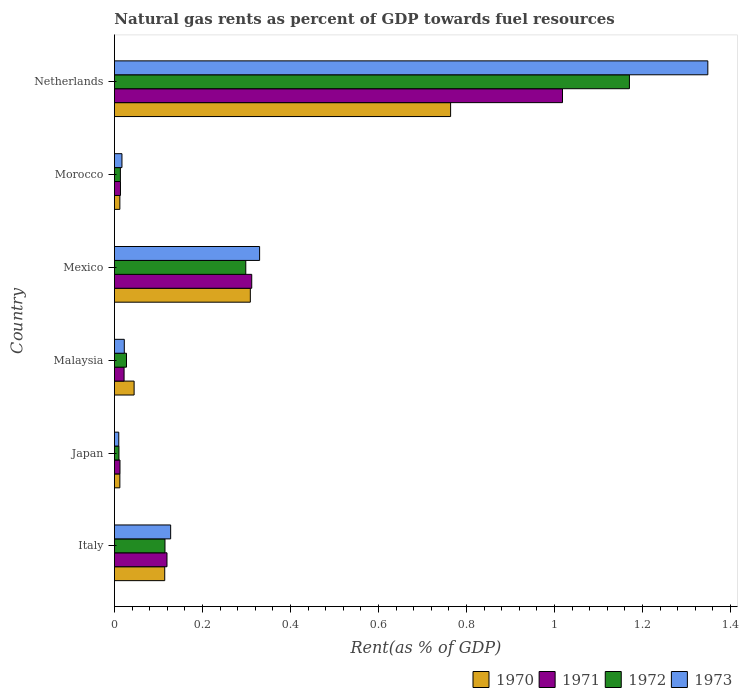How many different coloured bars are there?
Your response must be concise. 4. Are the number of bars per tick equal to the number of legend labels?
Your answer should be very brief. Yes. What is the label of the 2nd group of bars from the top?
Ensure brevity in your answer.  Morocco. What is the matural gas rent in 1973 in Netherlands?
Make the answer very short. 1.35. Across all countries, what is the maximum matural gas rent in 1971?
Provide a succinct answer. 1.02. Across all countries, what is the minimum matural gas rent in 1970?
Ensure brevity in your answer.  0.01. In which country was the matural gas rent in 1970 minimum?
Offer a terse response. Japan. What is the total matural gas rent in 1970 in the graph?
Provide a succinct answer. 1.26. What is the difference between the matural gas rent in 1973 in Japan and that in Mexico?
Ensure brevity in your answer.  -0.32. What is the difference between the matural gas rent in 1971 in Morocco and the matural gas rent in 1973 in Mexico?
Ensure brevity in your answer.  -0.32. What is the average matural gas rent in 1972 per country?
Ensure brevity in your answer.  0.27. What is the difference between the matural gas rent in 1970 and matural gas rent in 1973 in Netherlands?
Provide a succinct answer. -0.58. In how many countries, is the matural gas rent in 1971 greater than 0.28 %?
Provide a short and direct response. 2. What is the ratio of the matural gas rent in 1970 in Japan to that in Morocco?
Provide a succinct answer. 1. Is the difference between the matural gas rent in 1970 in Morocco and Netherlands greater than the difference between the matural gas rent in 1973 in Morocco and Netherlands?
Ensure brevity in your answer.  Yes. What is the difference between the highest and the second highest matural gas rent in 1973?
Keep it short and to the point. 1.02. What is the difference between the highest and the lowest matural gas rent in 1971?
Give a very brief answer. 1.01. Is the sum of the matural gas rent in 1971 in Malaysia and Morocco greater than the maximum matural gas rent in 1972 across all countries?
Offer a terse response. No. Is it the case that in every country, the sum of the matural gas rent in 1971 and matural gas rent in 1970 is greater than the sum of matural gas rent in 1972 and matural gas rent in 1973?
Your answer should be very brief. No. What does the 2nd bar from the top in Netherlands represents?
Provide a succinct answer. 1972. What does the 1st bar from the bottom in Japan represents?
Your answer should be very brief. 1970. Are all the bars in the graph horizontal?
Offer a very short reply. Yes. How are the legend labels stacked?
Offer a very short reply. Horizontal. What is the title of the graph?
Give a very brief answer. Natural gas rents as percent of GDP towards fuel resources. What is the label or title of the X-axis?
Offer a terse response. Rent(as % of GDP). What is the Rent(as % of GDP) of 1970 in Italy?
Provide a short and direct response. 0.11. What is the Rent(as % of GDP) in 1971 in Italy?
Provide a succinct answer. 0.12. What is the Rent(as % of GDP) in 1972 in Italy?
Make the answer very short. 0.11. What is the Rent(as % of GDP) in 1973 in Italy?
Your response must be concise. 0.13. What is the Rent(as % of GDP) in 1970 in Japan?
Ensure brevity in your answer.  0.01. What is the Rent(as % of GDP) in 1971 in Japan?
Provide a succinct answer. 0.01. What is the Rent(as % of GDP) in 1972 in Japan?
Your answer should be compact. 0.01. What is the Rent(as % of GDP) of 1973 in Japan?
Keep it short and to the point. 0.01. What is the Rent(as % of GDP) of 1970 in Malaysia?
Provide a succinct answer. 0.04. What is the Rent(as % of GDP) of 1971 in Malaysia?
Your answer should be very brief. 0.02. What is the Rent(as % of GDP) of 1972 in Malaysia?
Your response must be concise. 0.03. What is the Rent(as % of GDP) in 1973 in Malaysia?
Give a very brief answer. 0.02. What is the Rent(as % of GDP) of 1970 in Mexico?
Give a very brief answer. 0.31. What is the Rent(as % of GDP) in 1971 in Mexico?
Make the answer very short. 0.31. What is the Rent(as % of GDP) of 1972 in Mexico?
Your answer should be compact. 0.3. What is the Rent(as % of GDP) of 1973 in Mexico?
Provide a succinct answer. 0.33. What is the Rent(as % of GDP) in 1970 in Morocco?
Offer a terse response. 0.01. What is the Rent(as % of GDP) in 1971 in Morocco?
Your answer should be compact. 0.01. What is the Rent(as % of GDP) of 1972 in Morocco?
Provide a succinct answer. 0.01. What is the Rent(as % of GDP) of 1973 in Morocco?
Keep it short and to the point. 0.02. What is the Rent(as % of GDP) in 1970 in Netherlands?
Your answer should be compact. 0.76. What is the Rent(as % of GDP) in 1971 in Netherlands?
Give a very brief answer. 1.02. What is the Rent(as % of GDP) in 1972 in Netherlands?
Offer a terse response. 1.17. What is the Rent(as % of GDP) of 1973 in Netherlands?
Your answer should be compact. 1.35. Across all countries, what is the maximum Rent(as % of GDP) in 1970?
Make the answer very short. 0.76. Across all countries, what is the maximum Rent(as % of GDP) of 1971?
Provide a succinct answer. 1.02. Across all countries, what is the maximum Rent(as % of GDP) in 1972?
Keep it short and to the point. 1.17. Across all countries, what is the maximum Rent(as % of GDP) of 1973?
Your response must be concise. 1.35. Across all countries, what is the minimum Rent(as % of GDP) in 1970?
Your answer should be compact. 0.01. Across all countries, what is the minimum Rent(as % of GDP) in 1971?
Keep it short and to the point. 0.01. Across all countries, what is the minimum Rent(as % of GDP) in 1972?
Provide a succinct answer. 0.01. Across all countries, what is the minimum Rent(as % of GDP) in 1973?
Keep it short and to the point. 0.01. What is the total Rent(as % of GDP) in 1970 in the graph?
Keep it short and to the point. 1.26. What is the total Rent(as % of GDP) in 1971 in the graph?
Keep it short and to the point. 1.5. What is the total Rent(as % of GDP) in 1972 in the graph?
Offer a very short reply. 1.64. What is the total Rent(as % of GDP) of 1973 in the graph?
Offer a terse response. 1.86. What is the difference between the Rent(as % of GDP) of 1970 in Italy and that in Japan?
Your response must be concise. 0.1. What is the difference between the Rent(as % of GDP) in 1971 in Italy and that in Japan?
Make the answer very short. 0.11. What is the difference between the Rent(as % of GDP) of 1972 in Italy and that in Japan?
Keep it short and to the point. 0.1. What is the difference between the Rent(as % of GDP) of 1973 in Italy and that in Japan?
Provide a succinct answer. 0.12. What is the difference between the Rent(as % of GDP) of 1970 in Italy and that in Malaysia?
Give a very brief answer. 0.07. What is the difference between the Rent(as % of GDP) of 1971 in Italy and that in Malaysia?
Offer a very short reply. 0.1. What is the difference between the Rent(as % of GDP) in 1972 in Italy and that in Malaysia?
Make the answer very short. 0.09. What is the difference between the Rent(as % of GDP) in 1973 in Italy and that in Malaysia?
Your response must be concise. 0.11. What is the difference between the Rent(as % of GDP) of 1970 in Italy and that in Mexico?
Provide a succinct answer. -0.19. What is the difference between the Rent(as % of GDP) of 1971 in Italy and that in Mexico?
Ensure brevity in your answer.  -0.19. What is the difference between the Rent(as % of GDP) of 1972 in Italy and that in Mexico?
Give a very brief answer. -0.18. What is the difference between the Rent(as % of GDP) in 1973 in Italy and that in Mexico?
Offer a very short reply. -0.2. What is the difference between the Rent(as % of GDP) of 1970 in Italy and that in Morocco?
Provide a short and direct response. 0.1. What is the difference between the Rent(as % of GDP) in 1971 in Italy and that in Morocco?
Ensure brevity in your answer.  0.11. What is the difference between the Rent(as % of GDP) of 1972 in Italy and that in Morocco?
Offer a very short reply. 0.1. What is the difference between the Rent(as % of GDP) of 1973 in Italy and that in Morocco?
Make the answer very short. 0.11. What is the difference between the Rent(as % of GDP) in 1970 in Italy and that in Netherlands?
Your answer should be very brief. -0.65. What is the difference between the Rent(as % of GDP) of 1971 in Italy and that in Netherlands?
Keep it short and to the point. -0.9. What is the difference between the Rent(as % of GDP) of 1972 in Italy and that in Netherlands?
Your answer should be compact. -1.06. What is the difference between the Rent(as % of GDP) of 1973 in Italy and that in Netherlands?
Provide a short and direct response. -1.22. What is the difference between the Rent(as % of GDP) in 1970 in Japan and that in Malaysia?
Offer a very short reply. -0.03. What is the difference between the Rent(as % of GDP) of 1971 in Japan and that in Malaysia?
Your answer should be very brief. -0.01. What is the difference between the Rent(as % of GDP) of 1972 in Japan and that in Malaysia?
Make the answer very short. -0.02. What is the difference between the Rent(as % of GDP) in 1973 in Japan and that in Malaysia?
Keep it short and to the point. -0.01. What is the difference between the Rent(as % of GDP) of 1970 in Japan and that in Mexico?
Give a very brief answer. -0.3. What is the difference between the Rent(as % of GDP) in 1971 in Japan and that in Mexico?
Your response must be concise. -0.3. What is the difference between the Rent(as % of GDP) of 1972 in Japan and that in Mexico?
Your answer should be very brief. -0.29. What is the difference between the Rent(as % of GDP) in 1973 in Japan and that in Mexico?
Provide a succinct answer. -0.32. What is the difference between the Rent(as % of GDP) in 1971 in Japan and that in Morocco?
Your answer should be compact. -0. What is the difference between the Rent(as % of GDP) of 1972 in Japan and that in Morocco?
Ensure brevity in your answer.  -0. What is the difference between the Rent(as % of GDP) in 1973 in Japan and that in Morocco?
Make the answer very short. -0.01. What is the difference between the Rent(as % of GDP) of 1970 in Japan and that in Netherlands?
Make the answer very short. -0.75. What is the difference between the Rent(as % of GDP) of 1971 in Japan and that in Netherlands?
Offer a very short reply. -1.01. What is the difference between the Rent(as % of GDP) in 1972 in Japan and that in Netherlands?
Offer a very short reply. -1.16. What is the difference between the Rent(as % of GDP) of 1973 in Japan and that in Netherlands?
Offer a terse response. -1.34. What is the difference between the Rent(as % of GDP) of 1970 in Malaysia and that in Mexico?
Offer a terse response. -0.26. What is the difference between the Rent(as % of GDP) in 1971 in Malaysia and that in Mexico?
Ensure brevity in your answer.  -0.29. What is the difference between the Rent(as % of GDP) in 1972 in Malaysia and that in Mexico?
Offer a very short reply. -0.27. What is the difference between the Rent(as % of GDP) of 1973 in Malaysia and that in Mexico?
Your answer should be compact. -0.31. What is the difference between the Rent(as % of GDP) of 1970 in Malaysia and that in Morocco?
Your answer should be very brief. 0.03. What is the difference between the Rent(as % of GDP) of 1971 in Malaysia and that in Morocco?
Offer a very short reply. 0.01. What is the difference between the Rent(as % of GDP) in 1972 in Malaysia and that in Morocco?
Your response must be concise. 0.01. What is the difference between the Rent(as % of GDP) in 1973 in Malaysia and that in Morocco?
Your answer should be very brief. 0.01. What is the difference between the Rent(as % of GDP) in 1970 in Malaysia and that in Netherlands?
Offer a terse response. -0.72. What is the difference between the Rent(as % of GDP) in 1971 in Malaysia and that in Netherlands?
Make the answer very short. -1. What is the difference between the Rent(as % of GDP) in 1972 in Malaysia and that in Netherlands?
Offer a very short reply. -1.14. What is the difference between the Rent(as % of GDP) of 1973 in Malaysia and that in Netherlands?
Keep it short and to the point. -1.33. What is the difference between the Rent(as % of GDP) of 1970 in Mexico and that in Morocco?
Provide a short and direct response. 0.3. What is the difference between the Rent(as % of GDP) in 1971 in Mexico and that in Morocco?
Offer a very short reply. 0.3. What is the difference between the Rent(as % of GDP) of 1972 in Mexico and that in Morocco?
Provide a succinct answer. 0.28. What is the difference between the Rent(as % of GDP) in 1973 in Mexico and that in Morocco?
Offer a very short reply. 0.31. What is the difference between the Rent(as % of GDP) in 1970 in Mexico and that in Netherlands?
Your answer should be very brief. -0.46. What is the difference between the Rent(as % of GDP) of 1971 in Mexico and that in Netherlands?
Offer a very short reply. -0.71. What is the difference between the Rent(as % of GDP) of 1972 in Mexico and that in Netherlands?
Your answer should be compact. -0.87. What is the difference between the Rent(as % of GDP) of 1973 in Mexico and that in Netherlands?
Provide a short and direct response. -1.02. What is the difference between the Rent(as % of GDP) in 1970 in Morocco and that in Netherlands?
Keep it short and to the point. -0.75. What is the difference between the Rent(as % of GDP) of 1971 in Morocco and that in Netherlands?
Make the answer very short. -1. What is the difference between the Rent(as % of GDP) in 1972 in Morocco and that in Netherlands?
Offer a terse response. -1.16. What is the difference between the Rent(as % of GDP) of 1973 in Morocco and that in Netherlands?
Ensure brevity in your answer.  -1.33. What is the difference between the Rent(as % of GDP) of 1970 in Italy and the Rent(as % of GDP) of 1971 in Japan?
Keep it short and to the point. 0.1. What is the difference between the Rent(as % of GDP) in 1970 in Italy and the Rent(as % of GDP) in 1972 in Japan?
Your answer should be very brief. 0.1. What is the difference between the Rent(as % of GDP) of 1970 in Italy and the Rent(as % of GDP) of 1973 in Japan?
Keep it short and to the point. 0.1. What is the difference between the Rent(as % of GDP) in 1971 in Italy and the Rent(as % of GDP) in 1972 in Japan?
Provide a short and direct response. 0.11. What is the difference between the Rent(as % of GDP) in 1971 in Italy and the Rent(as % of GDP) in 1973 in Japan?
Make the answer very short. 0.11. What is the difference between the Rent(as % of GDP) of 1972 in Italy and the Rent(as % of GDP) of 1973 in Japan?
Make the answer very short. 0.1. What is the difference between the Rent(as % of GDP) in 1970 in Italy and the Rent(as % of GDP) in 1971 in Malaysia?
Make the answer very short. 0.09. What is the difference between the Rent(as % of GDP) of 1970 in Italy and the Rent(as % of GDP) of 1972 in Malaysia?
Offer a terse response. 0.09. What is the difference between the Rent(as % of GDP) of 1970 in Italy and the Rent(as % of GDP) of 1973 in Malaysia?
Provide a succinct answer. 0.09. What is the difference between the Rent(as % of GDP) in 1971 in Italy and the Rent(as % of GDP) in 1972 in Malaysia?
Keep it short and to the point. 0.09. What is the difference between the Rent(as % of GDP) in 1971 in Italy and the Rent(as % of GDP) in 1973 in Malaysia?
Ensure brevity in your answer.  0.1. What is the difference between the Rent(as % of GDP) of 1972 in Italy and the Rent(as % of GDP) of 1973 in Malaysia?
Offer a very short reply. 0.09. What is the difference between the Rent(as % of GDP) in 1970 in Italy and the Rent(as % of GDP) in 1971 in Mexico?
Keep it short and to the point. -0.2. What is the difference between the Rent(as % of GDP) in 1970 in Italy and the Rent(as % of GDP) in 1972 in Mexico?
Your response must be concise. -0.18. What is the difference between the Rent(as % of GDP) in 1970 in Italy and the Rent(as % of GDP) in 1973 in Mexico?
Provide a succinct answer. -0.22. What is the difference between the Rent(as % of GDP) in 1971 in Italy and the Rent(as % of GDP) in 1972 in Mexico?
Offer a terse response. -0.18. What is the difference between the Rent(as % of GDP) in 1971 in Italy and the Rent(as % of GDP) in 1973 in Mexico?
Make the answer very short. -0.21. What is the difference between the Rent(as % of GDP) in 1972 in Italy and the Rent(as % of GDP) in 1973 in Mexico?
Make the answer very short. -0.22. What is the difference between the Rent(as % of GDP) of 1970 in Italy and the Rent(as % of GDP) of 1971 in Morocco?
Make the answer very short. 0.1. What is the difference between the Rent(as % of GDP) in 1970 in Italy and the Rent(as % of GDP) in 1972 in Morocco?
Give a very brief answer. 0.1. What is the difference between the Rent(as % of GDP) of 1970 in Italy and the Rent(as % of GDP) of 1973 in Morocco?
Provide a succinct answer. 0.1. What is the difference between the Rent(as % of GDP) in 1971 in Italy and the Rent(as % of GDP) in 1972 in Morocco?
Offer a terse response. 0.11. What is the difference between the Rent(as % of GDP) of 1971 in Italy and the Rent(as % of GDP) of 1973 in Morocco?
Your answer should be very brief. 0.1. What is the difference between the Rent(as % of GDP) in 1972 in Italy and the Rent(as % of GDP) in 1973 in Morocco?
Make the answer very short. 0.1. What is the difference between the Rent(as % of GDP) in 1970 in Italy and the Rent(as % of GDP) in 1971 in Netherlands?
Offer a very short reply. -0.9. What is the difference between the Rent(as % of GDP) in 1970 in Italy and the Rent(as % of GDP) in 1972 in Netherlands?
Offer a very short reply. -1.06. What is the difference between the Rent(as % of GDP) of 1970 in Italy and the Rent(as % of GDP) of 1973 in Netherlands?
Ensure brevity in your answer.  -1.23. What is the difference between the Rent(as % of GDP) of 1971 in Italy and the Rent(as % of GDP) of 1972 in Netherlands?
Your response must be concise. -1.05. What is the difference between the Rent(as % of GDP) in 1971 in Italy and the Rent(as % of GDP) in 1973 in Netherlands?
Offer a terse response. -1.23. What is the difference between the Rent(as % of GDP) of 1972 in Italy and the Rent(as % of GDP) of 1973 in Netherlands?
Keep it short and to the point. -1.23. What is the difference between the Rent(as % of GDP) in 1970 in Japan and the Rent(as % of GDP) in 1971 in Malaysia?
Offer a very short reply. -0.01. What is the difference between the Rent(as % of GDP) in 1970 in Japan and the Rent(as % of GDP) in 1972 in Malaysia?
Your response must be concise. -0.02. What is the difference between the Rent(as % of GDP) in 1970 in Japan and the Rent(as % of GDP) in 1973 in Malaysia?
Ensure brevity in your answer.  -0.01. What is the difference between the Rent(as % of GDP) of 1971 in Japan and the Rent(as % of GDP) of 1972 in Malaysia?
Your answer should be compact. -0.01. What is the difference between the Rent(as % of GDP) in 1971 in Japan and the Rent(as % of GDP) in 1973 in Malaysia?
Offer a very short reply. -0.01. What is the difference between the Rent(as % of GDP) of 1972 in Japan and the Rent(as % of GDP) of 1973 in Malaysia?
Provide a succinct answer. -0.01. What is the difference between the Rent(as % of GDP) in 1970 in Japan and the Rent(as % of GDP) in 1971 in Mexico?
Give a very brief answer. -0.3. What is the difference between the Rent(as % of GDP) of 1970 in Japan and the Rent(as % of GDP) of 1972 in Mexico?
Ensure brevity in your answer.  -0.29. What is the difference between the Rent(as % of GDP) in 1970 in Japan and the Rent(as % of GDP) in 1973 in Mexico?
Offer a terse response. -0.32. What is the difference between the Rent(as % of GDP) in 1971 in Japan and the Rent(as % of GDP) in 1972 in Mexico?
Offer a very short reply. -0.29. What is the difference between the Rent(as % of GDP) in 1971 in Japan and the Rent(as % of GDP) in 1973 in Mexico?
Provide a short and direct response. -0.32. What is the difference between the Rent(as % of GDP) of 1972 in Japan and the Rent(as % of GDP) of 1973 in Mexico?
Offer a very short reply. -0.32. What is the difference between the Rent(as % of GDP) of 1970 in Japan and the Rent(as % of GDP) of 1971 in Morocco?
Offer a terse response. -0. What is the difference between the Rent(as % of GDP) in 1970 in Japan and the Rent(as % of GDP) in 1972 in Morocco?
Provide a short and direct response. -0. What is the difference between the Rent(as % of GDP) in 1970 in Japan and the Rent(as % of GDP) in 1973 in Morocco?
Ensure brevity in your answer.  -0. What is the difference between the Rent(as % of GDP) of 1971 in Japan and the Rent(as % of GDP) of 1972 in Morocco?
Your answer should be very brief. -0. What is the difference between the Rent(as % of GDP) of 1971 in Japan and the Rent(as % of GDP) of 1973 in Morocco?
Offer a very short reply. -0. What is the difference between the Rent(as % of GDP) in 1972 in Japan and the Rent(as % of GDP) in 1973 in Morocco?
Make the answer very short. -0.01. What is the difference between the Rent(as % of GDP) in 1970 in Japan and the Rent(as % of GDP) in 1971 in Netherlands?
Make the answer very short. -1.01. What is the difference between the Rent(as % of GDP) in 1970 in Japan and the Rent(as % of GDP) in 1972 in Netherlands?
Provide a succinct answer. -1.16. What is the difference between the Rent(as % of GDP) in 1970 in Japan and the Rent(as % of GDP) in 1973 in Netherlands?
Offer a terse response. -1.34. What is the difference between the Rent(as % of GDP) of 1971 in Japan and the Rent(as % of GDP) of 1972 in Netherlands?
Offer a terse response. -1.16. What is the difference between the Rent(as % of GDP) in 1971 in Japan and the Rent(as % of GDP) in 1973 in Netherlands?
Provide a short and direct response. -1.34. What is the difference between the Rent(as % of GDP) of 1972 in Japan and the Rent(as % of GDP) of 1973 in Netherlands?
Provide a succinct answer. -1.34. What is the difference between the Rent(as % of GDP) of 1970 in Malaysia and the Rent(as % of GDP) of 1971 in Mexico?
Provide a succinct answer. -0.27. What is the difference between the Rent(as % of GDP) of 1970 in Malaysia and the Rent(as % of GDP) of 1972 in Mexico?
Offer a terse response. -0.25. What is the difference between the Rent(as % of GDP) of 1970 in Malaysia and the Rent(as % of GDP) of 1973 in Mexico?
Keep it short and to the point. -0.29. What is the difference between the Rent(as % of GDP) in 1971 in Malaysia and the Rent(as % of GDP) in 1972 in Mexico?
Your answer should be very brief. -0.28. What is the difference between the Rent(as % of GDP) of 1971 in Malaysia and the Rent(as % of GDP) of 1973 in Mexico?
Your answer should be compact. -0.31. What is the difference between the Rent(as % of GDP) in 1972 in Malaysia and the Rent(as % of GDP) in 1973 in Mexico?
Your response must be concise. -0.3. What is the difference between the Rent(as % of GDP) in 1970 in Malaysia and the Rent(as % of GDP) in 1971 in Morocco?
Offer a terse response. 0.03. What is the difference between the Rent(as % of GDP) in 1970 in Malaysia and the Rent(as % of GDP) in 1972 in Morocco?
Keep it short and to the point. 0.03. What is the difference between the Rent(as % of GDP) in 1970 in Malaysia and the Rent(as % of GDP) in 1973 in Morocco?
Give a very brief answer. 0.03. What is the difference between the Rent(as % of GDP) of 1971 in Malaysia and the Rent(as % of GDP) of 1972 in Morocco?
Offer a terse response. 0.01. What is the difference between the Rent(as % of GDP) in 1971 in Malaysia and the Rent(as % of GDP) in 1973 in Morocco?
Ensure brevity in your answer.  0. What is the difference between the Rent(as % of GDP) of 1972 in Malaysia and the Rent(as % of GDP) of 1973 in Morocco?
Give a very brief answer. 0.01. What is the difference between the Rent(as % of GDP) of 1970 in Malaysia and the Rent(as % of GDP) of 1971 in Netherlands?
Your answer should be very brief. -0.97. What is the difference between the Rent(as % of GDP) of 1970 in Malaysia and the Rent(as % of GDP) of 1972 in Netherlands?
Provide a short and direct response. -1.13. What is the difference between the Rent(as % of GDP) of 1970 in Malaysia and the Rent(as % of GDP) of 1973 in Netherlands?
Offer a terse response. -1.3. What is the difference between the Rent(as % of GDP) of 1971 in Malaysia and the Rent(as % of GDP) of 1972 in Netherlands?
Your response must be concise. -1.15. What is the difference between the Rent(as % of GDP) in 1971 in Malaysia and the Rent(as % of GDP) in 1973 in Netherlands?
Give a very brief answer. -1.33. What is the difference between the Rent(as % of GDP) in 1972 in Malaysia and the Rent(as % of GDP) in 1973 in Netherlands?
Provide a succinct answer. -1.32. What is the difference between the Rent(as % of GDP) of 1970 in Mexico and the Rent(as % of GDP) of 1971 in Morocco?
Make the answer very short. 0.3. What is the difference between the Rent(as % of GDP) in 1970 in Mexico and the Rent(as % of GDP) in 1972 in Morocco?
Your answer should be compact. 0.3. What is the difference between the Rent(as % of GDP) of 1970 in Mexico and the Rent(as % of GDP) of 1973 in Morocco?
Ensure brevity in your answer.  0.29. What is the difference between the Rent(as % of GDP) in 1971 in Mexico and the Rent(as % of GDP) in 1972 in Morocco?
Your answer should be compact. 0.3. What is the difference between the Rent(as % of GDP) in 1971 in Mexico and the Rent(as % of GDP) in 1973 in Morocco?
Provide a short and direct response. 0.29. What is the difference between the Rent(as % of GDP) of 1972 in Mexico and the Rent(as % of GDP) of 1973 in Morocco?
Your response must be concise. 0.28. What is the difference between the Rent(as % of GDP) in 1970 in Mexico and the Rent(as % of GDP) in 1971 in Netherlands?
Your response must be concise. -0.71. What is the difference between the Rent(as % of GDP) in 1970 in Mexico and the Rent(as % of GDP) in 1972 in Netherlands?
Ensure brevity in your answer.  -0.86. What is the difference between the Rent(as % of GDP) of 1970 in Mexico and the Rent(as % of GDP) of 1973 in Netherlands?
Offer a terse response. -1.04. What is the difference between the Rent(as % of GDP) of 1971 in Mexico and the Rent(as % of GDP) of 1972 in Netherlands?
Make the answer very short. -0.86. What is the difference between the Rent(as % of GDP) of 1971 in Mexico and the Rent(as % of GDP) of 1973 in Netherlands?
Offer a very short reply. -1.04. What is the difference between the Rent(as % of GDP) in 1972 in Mexico and the Rent(as % of GDP) in 1973 in Netherlands?
Offer a very short reply. -1.05. What is the difference between the Rent(as % of GDP) of 1970 in Morocco and the Rent(as % of GDP) of 1971 in Netherlands?
Your answer should be very brief. -1.01. What is the difference between the Rent(as % of GDP) of 1970 in Morocco and the Rent(as % of GDP) of 1972 in Netherlands?
Make the answer very short. -1.16. What is the difference between the Rent(as % of GDP) of 1970 in Morocco and the Rent(as % of GDP) of 1973 in Netherlands?
Your response must be concise. -1.34. What is the difference between the Rent(as % of GDP) of 1971 in Morocco and the Rent(as % of GDP) of 1972 in Netherlands?
Offer a terse response. -1.16. What is the difference between the Rent(as % of GDP) in 1971 in Morocco and the Rent(as % of GDP) in 1973 in Netherlands?
Your answer should be compact. -1.33. What is the difference between the Rent(as % of GDP) of 1972 in Morocco and the Rent(as % of GDP) of 1973 in Netherlands?
Provide a short and direct response. -1.34. What is the average Rent(as % of GDP) of 1970 per country?
Provide a short and direct response. 0.21. What is the average Rent(as % of GDP) of 1971 per country?
Offer a terse response. 0.25. What is the average Rent(as % of GDP) in 1972 per country?
Offer a very short reply. 0.27. What is the average Rent(as % of GDP) in 1973 per country?
Make the answer very short. 0.31. What is the difference between the Rent(as % of GDP) in 1970 and Rent(as % of GDP) in 1971 in Italy?
Keep it short and to the point. -0.01. What is the difference between the Rent(as % of GDP) of 1970 and Rent(as % of GDP) of 1972 in Italy?
Ensure brevity in your answer.  -0. What is the difference between the Rent(as % of GDP) in 1970 and Rent(as % of GDP) in 1973 in Italy?
Make the answer very short. -0.01. What is the difference between the Rent(as % of GDP) in 1971 and Rent(as % of GDP) in 1972 in Italy?
Keep it short and to the point. 0. What is the difference between the Rent(as % of GDP) of 1971 and Rent(as % of GDP) of 1973 in Italy?
Your answer should be compact. -0.01. What is the difference between the Rent(as % of GDP) of 1972 and Rent(as % of GDP) of 1973 in Italy?
Make the answer very short. -0.01. What is the difference between the Rent(as % of GDP) of 1970 and Rent(as % of GDP) of 1971 in Japan?
Ensure brevity in your answer.  -0. What is the difference between the Rent(as % of GDP) of 1970 and Rent(as % of GDP) of 1972 in Japan?
Make the answer very short. 0. What is the difference between the Rent(as % of GDP) of 1970 and Rent(as % of GDP) of 1973 in Japan?
Offer a terse response. 0. What is the difference between the Rent(as % of GDP) in 1971 and Rent(as % of GDP) in 1972 in Japan?
Your answer should be compact. 0. What is the difference between the Rent(as % of GDP) in 1971 and Rent(as % of GDP) in 1973 in Japan?
Your answer should be very brief. 0. What is the difference between the Rent(as % of GDP) of 1970 and Rent(as % of GDP) of 1971 in Malaysia?
Ensure brevity in your answer.  0.02. What is the difference between the Rent(as % of GDP) in 1970 and Rent(as % of GDP) in 1972 in Malaysia?
Offer a terse response. 0.02. What is the difference between the Rent(as % of GDP) in 1970 and Rent(as % of GDP) in 1973 in Malaysia?
Provide a succinct answer. 0.02. What is the difference between the Rent(as % of GDP) in 1971 and Rent(as % of GDP) in 1972 in Malaysia?
Ensure brevity in your answer.  -0.01. What is the difference between the Rent(as % of GDP) of 1971 and Rent(as % of GDP) of 1973 in Malaysia?
Make the answer very short. -0. What is the difference between the Rent(as % of GDP) of 1972 and Rent(as % of GDP) of 1973 in Malaysia?
Keep it short and to the point. 0.01. What is the difference between the Rent(as % of GDP) in 1970 and Rent(as % of GDP) in 1971 in Mexico?
Your response must be concise. -0. What is the difference between the Rent(as % of GDP) of 1970 and Rent(as % of GDP) of 1972 in Mexico?
Your answer should be very brief. 0.01. What is the difference between the Rent(as % of GDP) in 1970 and Rent(as % of GDP) in 1973 in Mexico?
Make the answer very short. -0.02. What is the difference between the Rent(as % of GDP) of 1971 and Rent(as % of GDP) of 1972 in Mexico?
Your answer should be very brief. 0.01. What is the difference between the Rent(as % of GDP) in 1971 and Rent(as % of GDP) in 1973 in Mexico?
Make the answer very short. -0.02. What is the difference between the Rent(as % of GDP) in 1972 and Rent(as % of GDP) in 1973 in Mexico?
Your answer should be very brief. -0.03. What is the difference between the Rent(as % of GDP) of 1970 and Rent(as % of GDP) of 1971 in Morocco?
Provide a short and direct response. -0. What is the difference between the Rent(as % of GDP) of 1970 and Rent(as % of GDP) of 1972 in Morocco?
Make the answer very short. -0. What is the difference between the Rent(as % of GDP) of 1970 and Rent(as % of GDP) of 1973 in Morocco?
Your answer should be very brief. -0. What is the difference between the Rent(as % of GDP) in 1971 and Rent(as % of GDP) in 1972 in Morocco?
Make the answer very short. 0. What is the difference between the Rent(as % of GDP) in 1971 and Rent(as % of GDP) in 1973 in Morocco?
Make the answer very short. -0. What is the difference between the Rent(as % of GDP) in 1972 and Rent(as % of GDP) in 1973 in Morocco?
Provide a succinct answer. -0. What is the difference between the Rent(as % of GDP) of 1970 and Rent(as % of GDP) of 1971 in Netherlands?
Your response must be concise. -0.25. What is the difference between the Rent(as % of GDP) in 1970 and Rent(as % of GDP) in 1972 in Netherlands?
Provide a succinct answer. -0.41. What is the difference between the Rent(as % of GDP) in 1970 and Rent(as % of GDP) in 1973 in Netherlands?
Provide a succinct answer. -0.58. What is the difference between the Rent(as % of GDP) in 1971 and Rent(as % of GDP) in 1972 in Netherlands?
Ensure brevity in your answer.  -0.15. What is the difference between the Rent(as % of GDP) in 1971 and Rent(as % of GDP) in 1973 in Netherlands?
Your answer should be very brief. -0.33. What is the difference between the Rent(as % of GDP) of 1972 and Rent(as % of GDP) of 1973 in Netherlands?
Ensure brevity in your answer.  -0.18. What is the ratio of the Rent(as % of GDP) in 1970 in Italy to that in Japan?
Offer a terse response. 9.27. What is the ratio of the Rent(as % of GDP) of 1971 in Italy to that in Japan?
Your response must be concise. 9.46. What is the ratio of the Rent(as % of GDP) of 1972 in Italy to that in Japan?
Keep it short and to the point. 11.16. What is the ratio of the Rent(as % of GDP) of 1973 in Italy to that in Japan?
Your response must be concise. 12.96. What is the ratio of the Rent(as % of GDP) of 1970 in Italy to that in Malaysia?
Keep it short and to the point. 2.56. What is the ratio of the Rent(as % of GDP) in 1971 in Italy to that in Malaysia?
Provide a succinct answer. 5.45. What is the ratio of the Rent(as % of GDP) of 1972 in Italy to that in Malaysia?
Make the answer very short. 4.19. What is the ratio of the Rent(as % of GDP) in 1973 in Italy to that in Malaysia?
Your answer should be compact. 5.7. What is the ratio of the Rent(as % of GDP) in 1970 in Italy to that in Mexico?
Ensure brevity in your answer.  0.37. What is the ratio of the Rent(as % of GDP) in 1971 in Italy to that in Mexico?
Your answer should be compact. 0.38. What is the ratio of the Rent(as % of GDP) in 1972 in Italy to that in Mexico?
Ensure brevity in your answer.  0.38. What is the ratio of the Rent(as % of GDP) of 1973 in Italy to that in Mexico?
Your answer should be compact. 0.39. What is the ratio of the Rent(as % of GDP) of 1970 in Italy to that in Morocco?
Provide a short and direct response. 9.25. What is the ratio of the Rent(as % of GDP) in 1971 in Italy to that in Morocco?
Your response must be concise. 8.7. What is the ratio of the Rent(as % of GDP) in 1972 in Italy to that in Morocco?
Provide a succinct answer. 8.48. What is the ratio of the Rent(as % of GDP) in 1973 in Italy to that in Morocco?
Offer a terse response. 7.47. What is the ratio of the Rent(as % of GDP) of 1970 in Italy to that in Netherlands?
Keep it short and to the point. 0.15. What is the ratio of the Rent(as % of GDP) in 1971 in Italy to that in Netherlands?
Provide a succinct answer. 0.12. What is the ratio of the Rent(as % of GDP) in 1972 in Italy to that in Netherlands?
Provide a succinct answer. 0.1. What is the ratio of the Rent(as % of GDP) of 1973 in Italy to that in Netherlands?
Ensure brevity in your answer.  0.09. What is the ratio of the Rent(as % of GDP) in 1970 in Japan to that in Malaysia?
Give a very brief answer. 0.28. What is the ratio of the Rent(as % of GDP) of 1971 in Japan to that in Malaysia?
Your answer should be very brief. 0.58. What is the ratio of the Rent(as % of GDP) of 1972 in Japan to that in Malaysia?
Your response must be concise. 0.38. What is the ratio of the Rent(as % of GDP) of 1973 in Japan to that in Malaysia?
Your answer should be compact. 0.44. What is the ratio of the Rent(as % of GDP) in 1970 in Japan to that in Mexico?
Your answer should be compact. 0.04. What is the ratio of the Rent(as % of GDP) of 1971 in Japan to that in Mexico?
Make the answer very short. 0.04. What is the ratio of the Rent(as % of GDP) of 1972 in Japan to that in Mexico?
Your response must be concise. 0.03. What is the ratio of the Rent(as % of GDP) of 1973 in Japan to that in Mexico?
Offer a terse response. 0.03. What is the ratio of the Rent(as % of GDP) in 1971 in Japan to that in Morocco?
Provide a succinct answer. 0.92. What is the ratio of the Rent(as % of GDP) in 1972 in Japan to that in Morocco?
Provide a succinct answer. 0.76. What is the ratio of the Rent(as % of GDP) of 1973 in Japan to that in Morocco?
Your answer should be very brief. 0.58. What is the ratio of the Rent(as % of GDP) of 1970 in Japan to that in Netherlands?
Make the answer very short. 0.02. What is the ratio of the Rent(as % of GDP) of 1971 in Japan to that in Netherlands?
Your response must be concise. 0.01. What is the ratio of the Rent(as % of GDP) in 1972 in Japan to that in Netherlands?
Your answer should be compact. 0.01. What is the ratio of the Rent(as % of GDP) in 1973 in Japan to that in Netherlands?
Provide a succinct answer. 0.01. What is the ratio of the Rent(as % of GDP) in 1970 in Malaysia to that in Mexico?
Provide a succinct answer. 0.14. What is the ratio of the Rent(as % of GDP) in 1971 in Malaysia to that in Mexico?
Your response must be concise. 0.07. What is the ratio of the Rent(as % of GDP) of 1972 in Malaysia to that in Mexico?
Offer a very short reply. 0.09. What is the ratio of the Rent(as % of GDP) in 1973 in Malaysia to that in Mexico?
Offer a very short reply. 0.07. What is the ratio of the Rent(as % of GDP) of 1970 in Malaysia to that in Morocco?
Your response must be concise. 3.62. What is the ratio of the Rent(as % of GDP) of 1971 in Malaysia to that in Morocco?
Your answer should be very brief. 1.6. What is the ratio of the Rent(as % of GDP) of 1972 in Malaysia to that in Morocco?
Keep it short and to the point. 2.03. What is the ratio of the Rent(as % of GDP) in 1973 in Malaysia to that in Morocco?
Keep it short and to the point. 1.31. What is the ratio of the Rent(as % of GDP) in 1970 in Malaysia to that in Netherlands?
Provide a short and direct response. 0.06. What is the ratio of the Rent(as % of GDP) of 1971 in Malaysia to that in Netherlands?
Make the answer very short. 0.02. What is the ratio of the Rent(as % of GDP) in 1972 in Malaysia to that in Netherlands?
Offer a very short reply. 0.02. What is the ratio of the Rent(as % of GDP) in 1973 in Malaysia to that in Netherlands?
Your answer should be compact. 0.02. What is the ratio of the Rent(as % of GDP) of 1970 in Mexico to that in Morocco?
Keep it short and to the point. 25. What is the ratio of the Rent(as % of GDP) in 1971 in Mexico to that in Morocco?
Give a very brief answer. 22.74. What is the ratio of the Rent(as % of GDP) of 1972 in Mexico to that in Morocco?
Make the answer very short. 22.04. What is the ratio of the Rent(as % of GDP) of 1973 in Mexico to that in Morocco?
Offer a terse response. 19.3. What is the ratio of the Rent(as % of GDP) of 1970 in Mexico to that in Netherlands?
Your answer should be very brief. 0.4. What is the ratio of the Rent(as % of GDP) in 1971 in Mexico to that in Netherlands?
Give a very brief answer. 0.31. What is the ratio of the Rent(as % of GDP) in 1972 in Mexico to that in Netherlands?
Provide a short and direct response. 0.26. What is the ratio of the Rent(as % of GDP) of 1973 in Mexico to that in Netherlands?
Offer a terse response. 0.24. What is the ratio of the Rent(as % of GDP) in 1970 in Morocco to that in Netherlands?
Ensure brevity in your answer.  0.02. What is the ratio of the Rent(as % of GDP) in 1971 in Morocco to that in Netherlands?
Your answer should be very brief. 0.01. What is the ratio of the Rent(as % of GDP) in 1972 in Morocco to that in Netherlands?
Your answer should be very brief. 0.01. What is the ratio of the Rent(as % of GDP) of 1973 in Morocco to that in Netherlands?
Ensure brevity in your answer.  0.01. What is the difference between the highest and the second highest Rent(as % of GDP) of 1970?
Make the answer very short. 0.46. What is the difference between the highest and the second highest Rent(as % of GDP) of 1971?
Offer a very short reply. 0.71. What is the difference between the highest and the second highest Rent(as % of GDP) in 1972?
Provide a short and direct response. 0.87. What is the difference between the highest and the second highest Rent(as % of GDP) in 1973?
Offer a very short reply. 1.02. What is the difference between the highest and the lowest Rent(as % of GDP) of 1970?
Your answer should be very brief. 0.75. What is the difference between the highest and the lowest Rent(as % of GDP) in 1971?
Give a very brief answer. 1.01. What is the difference between the highest and the lowest Rent(as % of GDP) in 1972?
Offer a terse response. 1.16. What is the difference between the highest and the lowest Rent(as % of GDP) in 1973?
Provide a succinct answer. 1.34. 